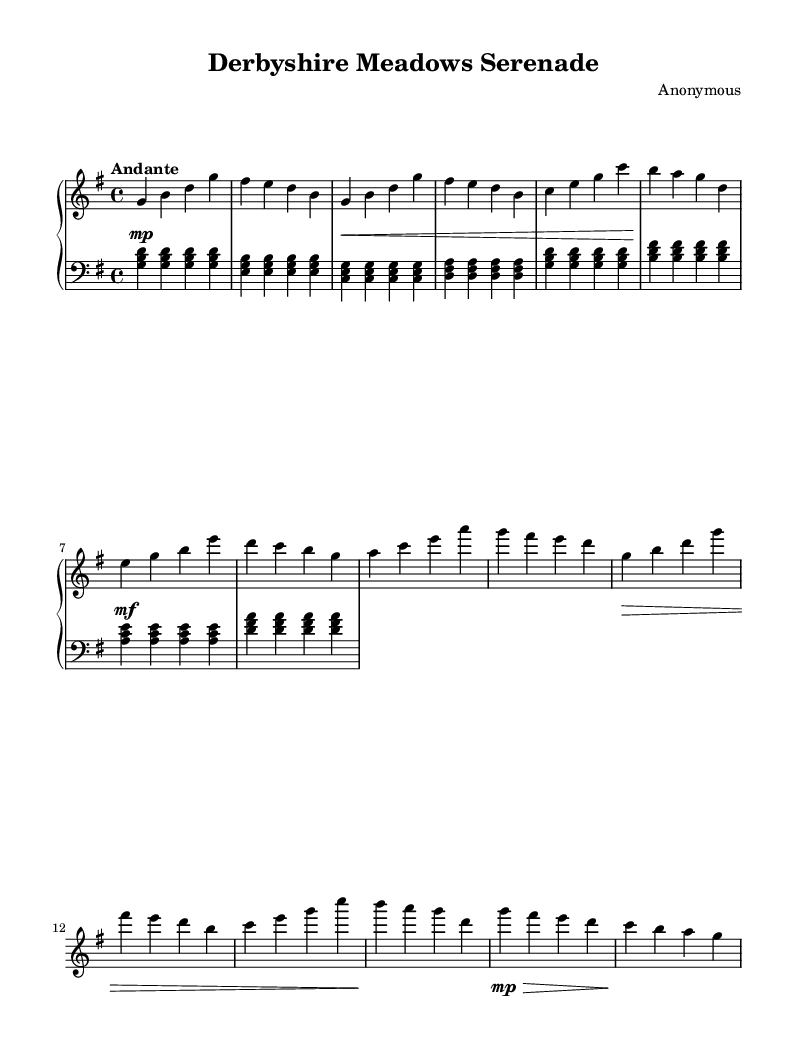What is the key signature of this music? The key signature features one sharp (F#), which indicates it is in G major.
Answer: G major What is the time signature of the piece? The time signature is placed at the beginning of the music and displays a 4 over 4, indicating four beats per measure.
Answer: 4/4 What tempo marking is used in this score? The tempo marking is given as "Andante," which suggests a moderately slow pace.
Answer: Andante How many measures are in the right-hand part? By counting the individual measures in the right-hand part, there are a total of 12 measures.
Answer: 12 Which section follows the 'A' section in this piece? Looking at the structure, the 'B' section logically follows the 'A' section, indicated by the progression of musical themes.
Answer: B section What dynamic marking starts the piece? At the beginning of the piece, the dynamic marking is pianissimo (soft), indicated by "mp", which signifies a soft beginning.
Answer: pianissimo What style of music is represented in this score? The structure, expressive phrasing, and harmonic progressions suggest that it is a Romantic piano ballad, a characteristic style marked by emotional expression.
Answer: Romantic piano ballad 